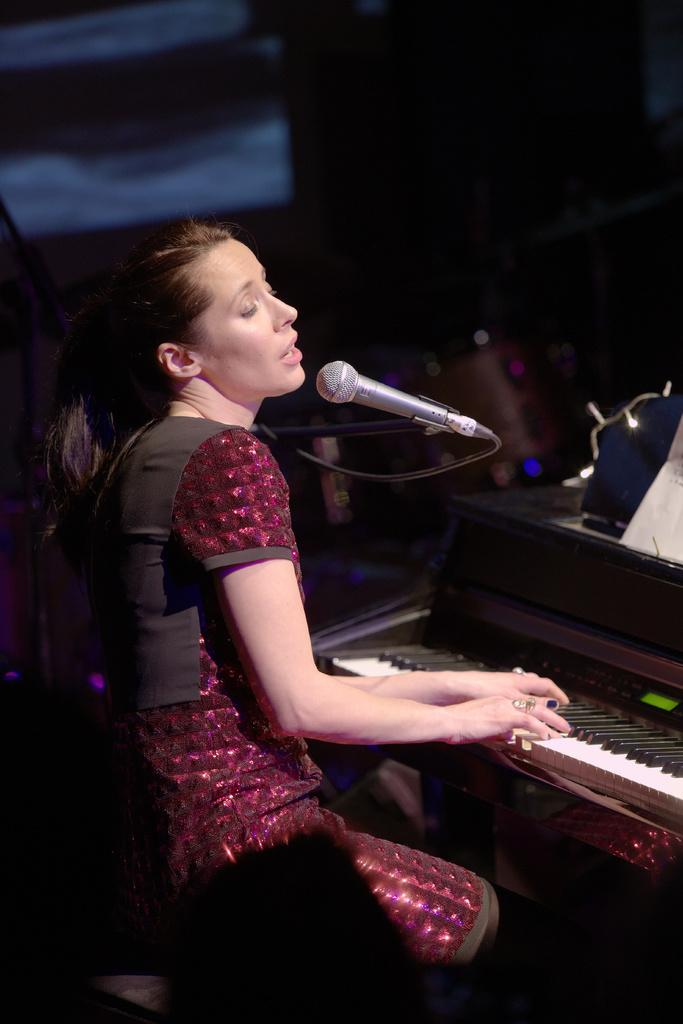Who is the main subject in the image? There is a girl in the image. What is the girl doing in the image? The girl is sitting on a chair and playing a musical instrument. What object is in front of the girl? There is a microphone in front of the girl. What type of sweater is the girl wearing in the image? There is no information about the girl's clothing in the provided facts, so we cannot determine if she is wearing a sweater or what type it might be. How does the heat affect the girl's performance in the image? There is no information about the temperature or weather conditions in the image, so we cannot determine how heat might affect the girl's performance. 